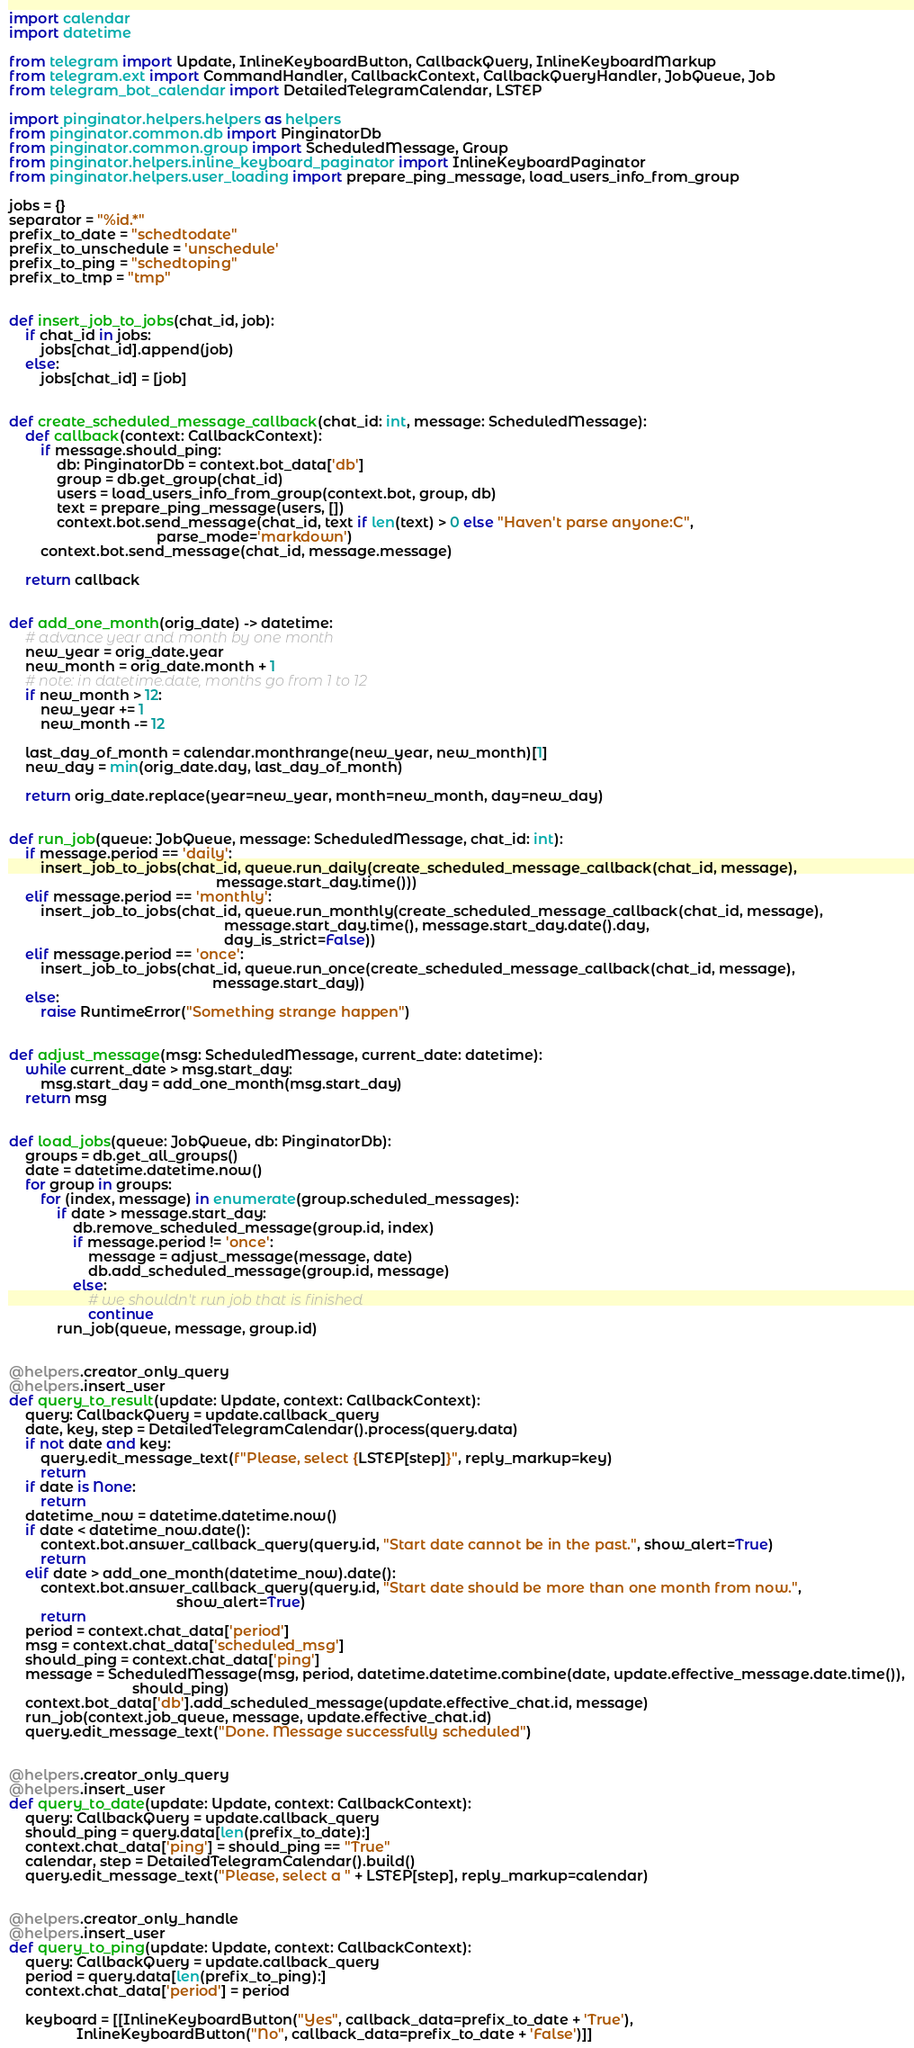<code> <loc_0><loc_0><loc_500><loc_500><_Python_>import calendar
import datetime

from telegram import Update, InlineKeyboardButton, CallbackQuery, InlineKeyboardMarkup
from telegram.ext import CommandHandler, CallbackContext, CallbackQueryHandler, JobQueue, Job
from telegram_bot_calendar import DetailedTelegramCalendar, LSTEP

import pinginator.helpers.helpers as helpers
from pinginator.common.db import PinginatorDb
from pinginator.common.group import ScheduledMessage, Group
from pinginator.helpers.inline_keyboard_paginator import InlineKeyboardPaginator
from pinginator.helpers.user_loading import prepare_ping_message, load_users_info_from_group

jobs = {}
separator = "%id.*"
prefix_to_date = "schedtodate"
prefix_to_unschedule = 'unschedule'
prefix_to_ping = "schedtoping"
prefix_to_tmp = "tmp"


def insert_job_to_jobs(chat_id, job):
    if chat_id in jobs:
        jobs[chat_id].append(job)
    else:
        jobs[chat_id] = [job]


def create_scheduled_message_callback(chat_id: int, message: ScheduledMessage):
    def callback(context: CallbackContext):
        if message.should_ping:
            db: PinginatorDb = context.bot_data['db']
            group = db.get_group(chat_id)
            users = load_users_info_from_group(context.bot, group, db)
            text = prepare_ping_message(users, [])
            context.bot.send_message(chat_id, text if len(text) > 0 else "Haven't parse anyone:C",
                                     parse_mode='markdown')
        context.bot.send_message(chat_id, message.message)

    return callback


def add_one_month(orig_date) -> datetime:
    # advance year and month by one month
    new_year = orig_date.year
    new_month = orig_date.month + 1
    # note: in datetime.date, months go from 1 to 12
    if new_month > 12:
        new_year += 1
        new_month -= 12

    last_day_of_month = calendar.monthrange(new_year, new_month)[1]
    new_day = min(orig_date.day, last_day_of_month)

    return orig_date.replace(year=new_year, month=new_month, day=new_day)


def run_job(queue: JobQueue, message: ScheduledMessage, chat_id: int):
    if message.period == 'daily':
        insert_job_to_jobs(chat_id, queue.run_daily(create_scheduled_message_callback(chat_id, message),
                                                    message.start_day.time()))
    elif message.period == 'monthly':
        insert_job_to_jobs(chat_id, queue.run_monthly(create_scheduled_message_callback(chat_id, message),
                                                      message.start_day.time(), message.start_day.date().day,
                                                      day_is_strict=False))
    elif message.period == 'once':
        insert_job_to_jobs(chat_id, queue.run_once(create_scheduled_message_callback(chat_id, message),
                                                   message.start_day))
    else:
        raise RuntimeError("Something strange happen")


def adjust_message(msg: ScheduledMessage, current_date: datetime):
    while current_date > msg.start_day:
        msg.start_day = add_one_month(msg.start_day)
    return msg


def load_jobs(queue: JobQueue, db: PinginatorDb):
    groups = db.get_all_groups()
    date = datetime.datetime.now()
    for group in groups:
        for (index, message) in enumerate(group.scheduled_messages):
            if date > message.start_day:
                db.remove_scheduled_message(group.id, index)
                if message.period != 'once':
                    message = adjust_message(message, date)
                    db.add_scheduled_message(group.id, message)
                else:
                    # we shouldn't run job that is finished
                    continue
            run_job(queue, message, group.id)


@helpers.creator_only_query
@helpers.insert_user
def query_to_result(update: Update, context: CallbackContext):
    query: CallbackQuery = update.callback_query
    date, key, step = DetailedTelegramCalendar().process(query.data)
    if not date and key:
        query.edit_message_text(f"Please, select {LSTEP[step]}", reply_markup=key)
        return
    if date is None:
        return
    datetime_now = datetime.datetime.now()
    if date < datetime_now.date():
        context.bot.answer_callback_query(query.id, "Start date cannot be in the past.", show_alert=True)
        return
    elif date > add_one_month(datetime_now).date():
        context.bot.answer_callback_query(query.id, "Start date should be more than one month from now.",
                                          show_alert=True)
        return
    period = context.chat_data['period']
    msg = context.chat_data['scheduled_msg']
    should_ping = context.chat_data['ping']
    message = ScheduledMessage(msg, period, datetime.datetime.combine(date, update.effective_message.date.time()),
                               should_ping)
    context.bot_data['db'].add_scheduled_message(update.effective_chat.id, message)
    run_job(context.job_queue, message, update.effective_chat.id)
    query.edit_message_text("Done. Message successfully scheduled")


@helpers.creator_only_query
@helpers.insert_user
def query_to_date(update: Update, context: CallbackContext):
    query: CallbackQuery = update.callback_query
    should_ping = query.data[len(prefix_to_date):]
    context.chat_data['ping'] = should_ping == "True"
    calendar, step = DetailedTelegramCalendar().build()
    query.edit_message_text("Please, select a " + LSTEP[step], reply_markup=calendar)


@helpers.creator_only_handle
@helpers.insert_user
def query_to_ping(update: Update, context: CallbackContext):
    query: CallbackQuery = update.callback_query
    period = query.data[len(prefix_to_ping):]
    context.chat_data['period'] = period

    keyboard = [[InlineKeyboardButton("Yes", callback_data=prefix_to_date + 'True'),
                 InlineKeyboardButton("No", callback_data=prefix_to_date + 'False')]]</code> 